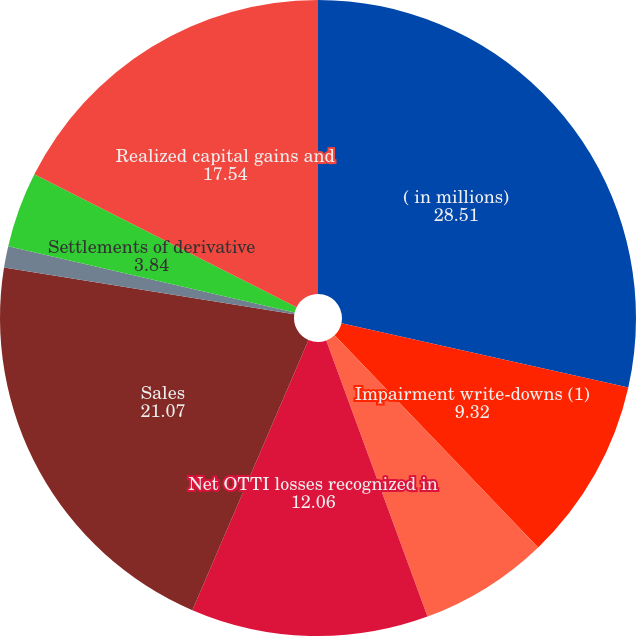<chart> <loc_0><loc_0><loc_500><loc_500><pie_chart><fcel>( in millions)<fcel>Impairment write-downs (1)<fcel>Change in intent write-downs<fcel>Net OTTI losses recognized in<fcel>Sales<fcel>Valuation of derivative<fcel>Settlements of derivative<fcel>Realized capital gains and<nl><fcel>28.51%<fcel>9.32%<fcel>6.58%<fcel>12.06%<fcel>21.07%<fcel>1.09%<fcel>3.84%<fcel>17.54%<nl></chart> 